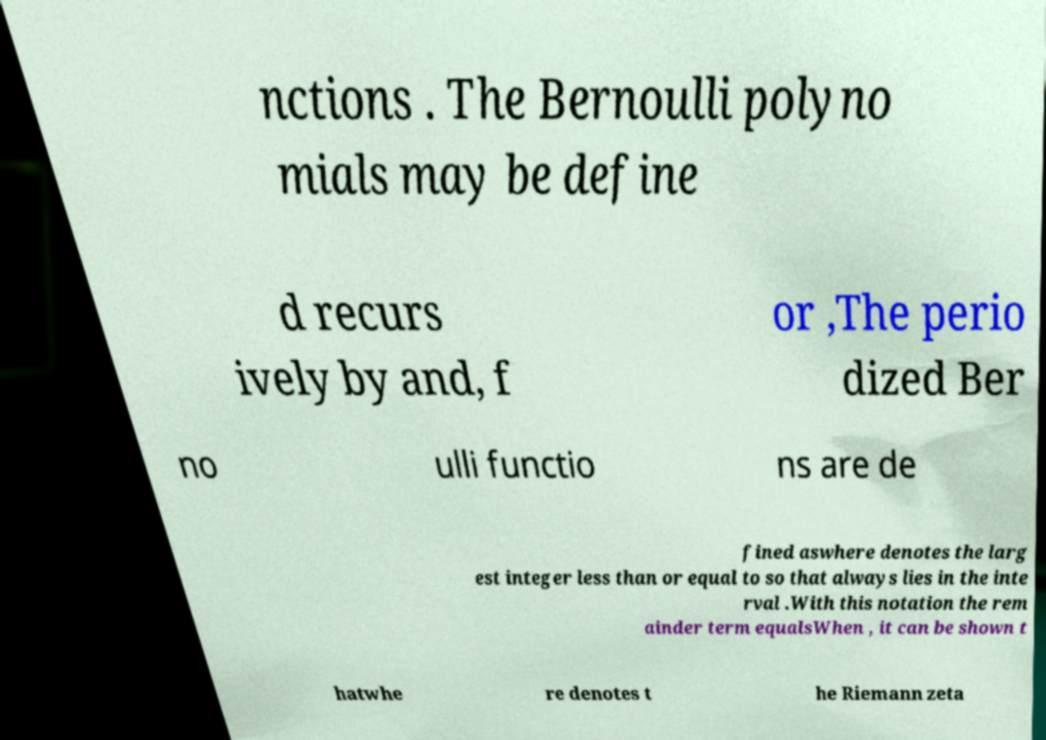Could you extract and type out the text from this image? nctions . The Bernoulli polyno mials may be define d recurs ively by and, f or ,The perio dized Ber no ulli functio ns are de fined aswhere denotes the larg est integer less than or equal to so that always lies in the inte rval .With this notation the rem ainder term equalsWhen , it can be shown t hatwhe re denotes t he Riemann zeta 